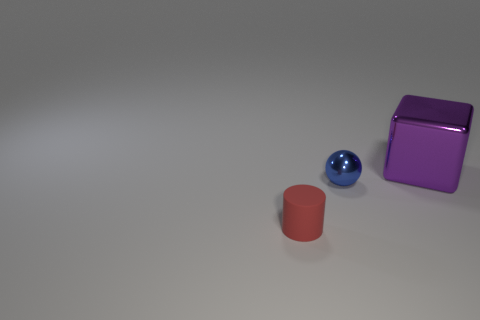Add 1 large shiny objects. How many large shiny objects exist? 2 Add 2 cylinders. How many objects exist? 5 Subtract 0 green cylinders. How many objects are left? 3 Subtract all cylinders. How many objects are left? 2 Subtract 1 spheres. How many spheres are left? 0 Subtract all brown spheres. Subtract all cyan cylinders. How many spheres are left? 1 Subtract all blue things. Subtract all matte things. How many objects are left? 1 Add 1 tiny blue spheres. How many tiny blue spheres are left? 2 